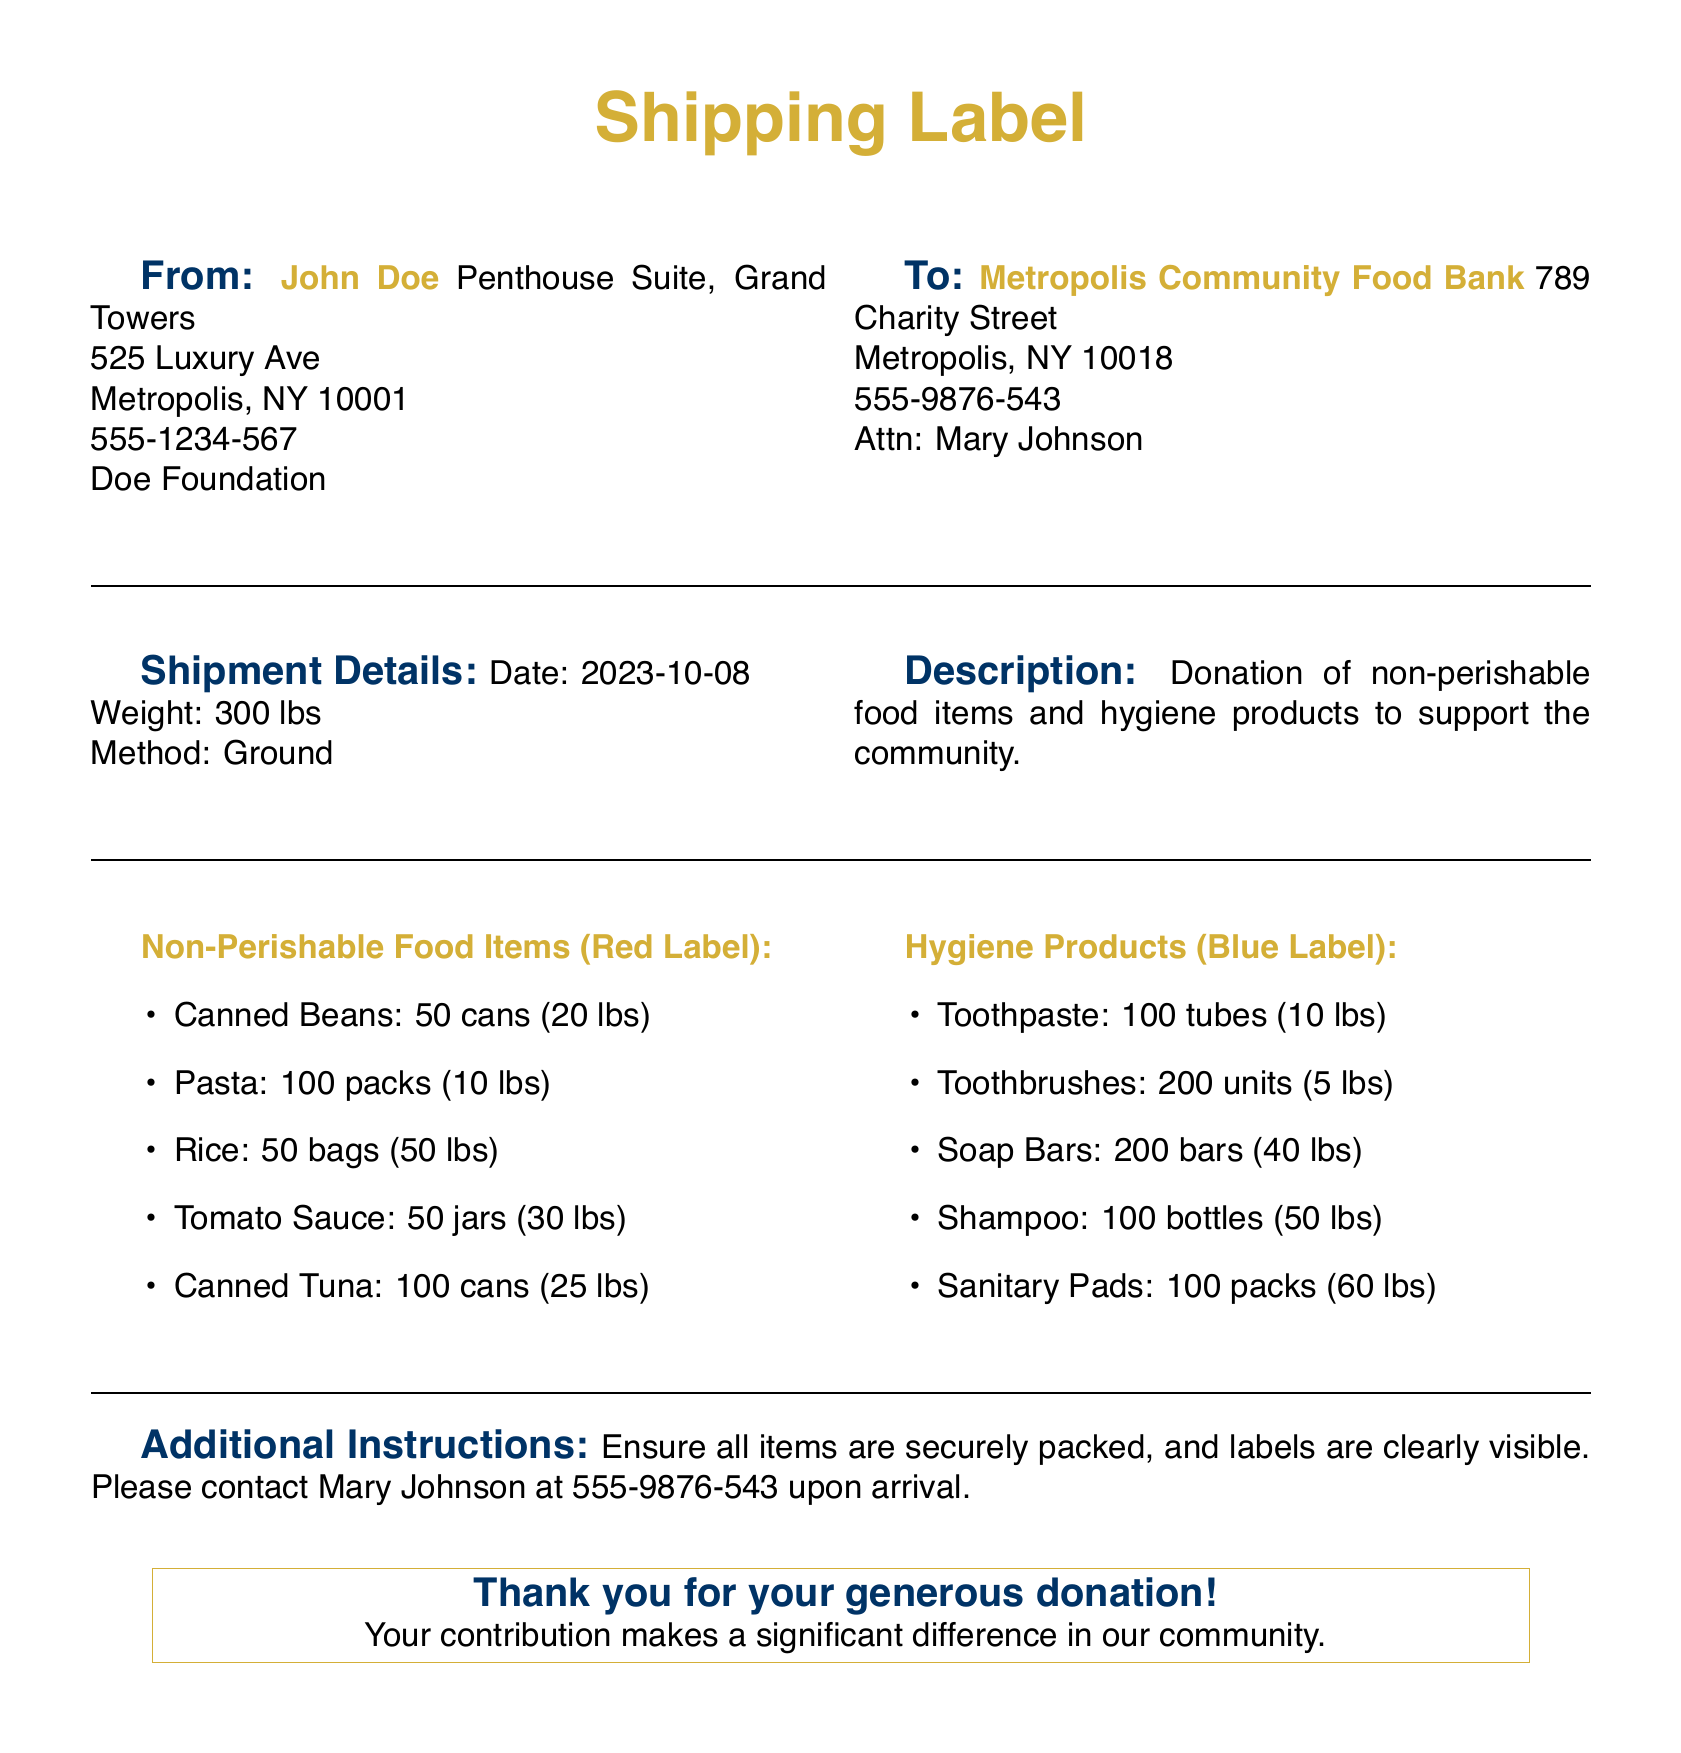What is the sender's name? The sender's name is provided in the "From" section of the document.
Answer: John Doe What is the recipient's address? The recipient's address can be found in the "To" section of the document.
Answer: 789 Charity Street, Metropolis, NY 10018 What is the total weight of the shipment? The total weight of the shipment is specified in the "Shipment Details" section.
Answer: 300 lbs When was the shipment date? The shipment date is recorded in the "Shipment Details" section.
Answer: 2023-10-08 How many cans of canned beans are included? The number of cans of canned beans is listed under "Non-Perishable Food Items".
Answer: 50 cans What types of hygiene products are mentioned? The types of hygiene products are specified in the "Hygiene Products" section.
Answer: Toothpaste, Toothbrushes, Soap Bars, Shampoo, Sanitary Pads What does the red label indicate? The red label highlights the category of products listed under it.
Answer: Non-Perishable Food Items What should be done upon arrival? This can be found in the "Additional Instructions" section regarding the contact information.
Answer: Contact Mary Johnson What is the weight of the shampoo included? The weight of the shampoo is listed under "Hygiene Products".
Answer: 50 lbs 